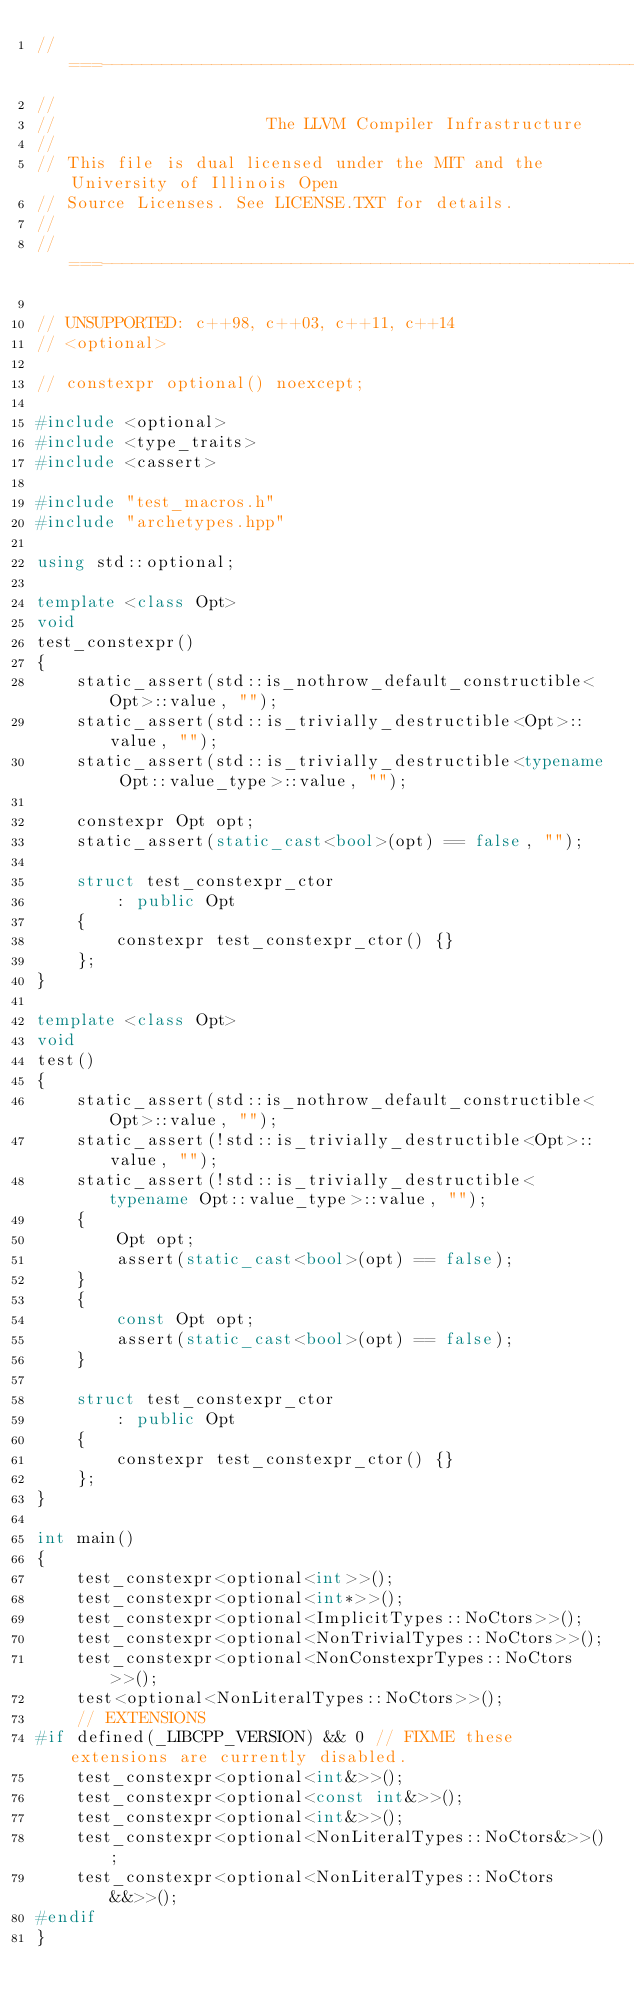Convert code to text. <code><loc_0><loc_0><loc_500><loc_500><_C++_>//===----------------------------------------------------------------------===//
//
//                     The LLVM Compiler Infrastructure
//
// This file is dual licensed under the MIT and the University of Illinois Open
// Source Licenses. See LICENSE.TXT for details.
//
//===----------------------------------------------------------------------===//

// UNSUPPORTED: c++98, c++03, c++11, c++14
// <optional>

// constexpr optional() noexcept;

#include <optional>
#include <type_traits>
#include <cassert>

#include "test_macros.h"
#include "archetypes.hpp"

using std::optional;

template <class Opt>
void
test_constexpr()
{
    static_assert(std::is_nothrow_default_constructible<Opt>::value, "");
    static_assert(std::is_trivially_destructible<Opt>::value, "");
    static_assert(std::is_trivially_destructible<typename Opt::value_type>::value, "");

    constexpr Opt opt;
    static_assert(static_cast<bool>(opt) == false, "");

    struct test_constexpr_ctor
        : public Opt
    {
        constexpr test_constexpr_ctor() {}
    };
}

template <class Opt>
void
test()
{
    static_assert(std::is_nothrow_default_constructible<Opt>::value, "");
    static_assert(!std::is_trivially_destructible<Opt>::value, "");
    static_assert(!std::is_trivially_destructible<typename Opt::value_type>::value, "");
    {
        Opt opt;
        assert(static_cast<bool>(opt) == false);
    }
    {
        const Opt opt;
        assert(static_cast<bool>(opt) == false);
    }

    struct test_constexpr_ctor
        : public Opt
    {
        constexpr test_constexpr_ctor() {}
    };
}

int main()
{
    test_constexpr<optional<int>>();
    test_constexpr<optional<int*>>();
    test_constexpr<optional<ImplicitTypes::NoCtors>>();
    test_constexpr<optional<NonTrivialTypes::NoCtors>>();
    test_constexpr<optional<NonConstexprTypes::NoCtors>>();
    test<optional<NonLiteralTypes::NoCtors>>();
    // EXTENSIONS
#if defined(_LIBCPP_VERSION) && 0 // FIXME these extensions are currently disabled.
    test_constexpr<optional<int&>>();
    test_constexpr<optional<const int&>>();
    test_constexpr<optional<int&>>();
    test_constexpr<optional<NonLiteralTypes::NoCtors&>>();
    test_constexpr<optional<NonLiteralTypes::NoCtors&&>>();
#endif
}
</code> 